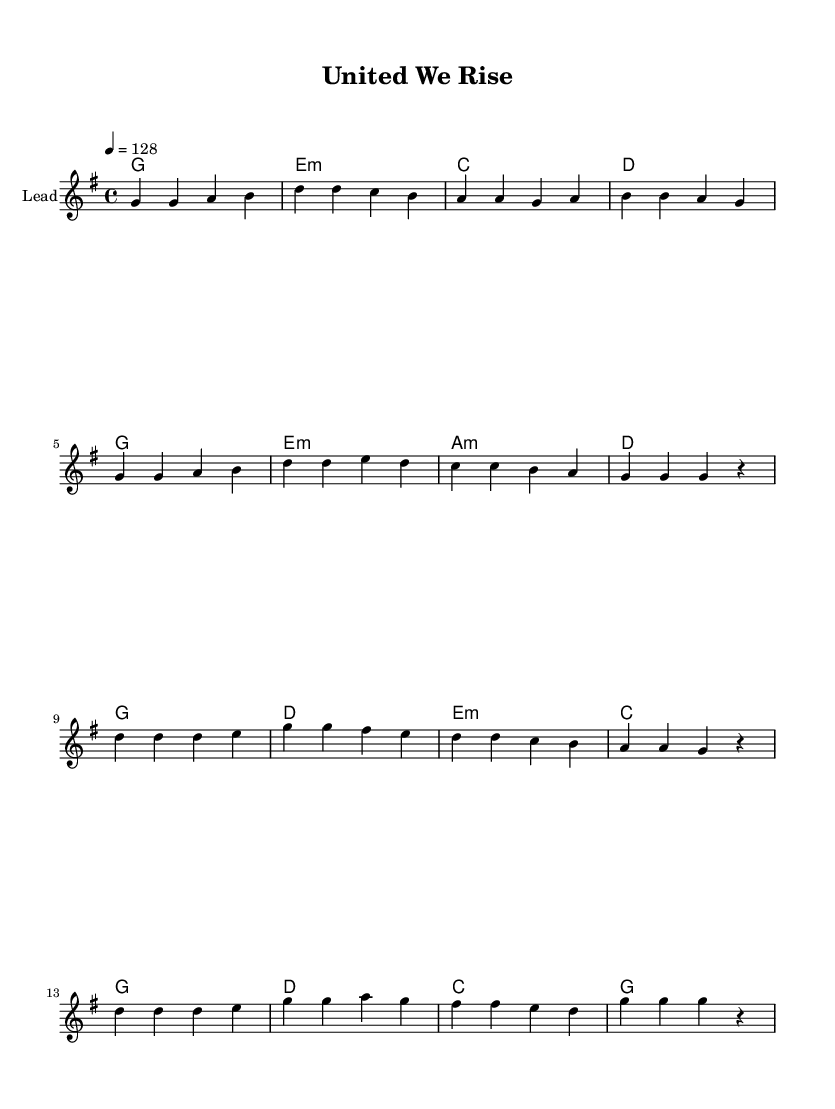What is the key signature of this music? The key signature is G major, indicated by one sharp (F#). You can identify the key signature by looking at the beginning of the staff, where the sharp appears.
Answer: G major What is the time signature of the piece? The time signature is 4/4, which means there are four beats in each measure and the quarter note gets one beat. This is shown at the beginning of the staff right after the key signature.
Answer: 4/4 What is the tempo marking for the music? The tempo marking is 128 beats per minute, indicated by the number after the tempo directive. This specifies how fast the piece should be played.
Answer: 128 How many measures are in the verse section? The verse section consists of eight measures as counted from the notation provided in the melody part. This is identifiable by counting the grouped notes and measures in that section.
Answer: 8 How many notes are in the chorus? The chorus contains 16 notes, which are counted by tallying each individual note shown in the melody section of the chorus. Each articulation corresponds to a single note.
Answer: 16 What thematic element does this song emphasize based on its lyrics and title? The song emphasizes teamwork and unity as indicated by the lyrics like "united we stand" and the title "United We Rise." These phrases reflect the thematic focus of collaboration and sportsmanship.
Answer: Teamwork What is the predominant emotional tone of this K-Pop anthem? The emotional tone is motivational, as the lyrics and rhythm aim to inspire strength and unity among people. This can be inferred from the encouraging language and uplifting melody used throughout the song.
Answer: Motivational 